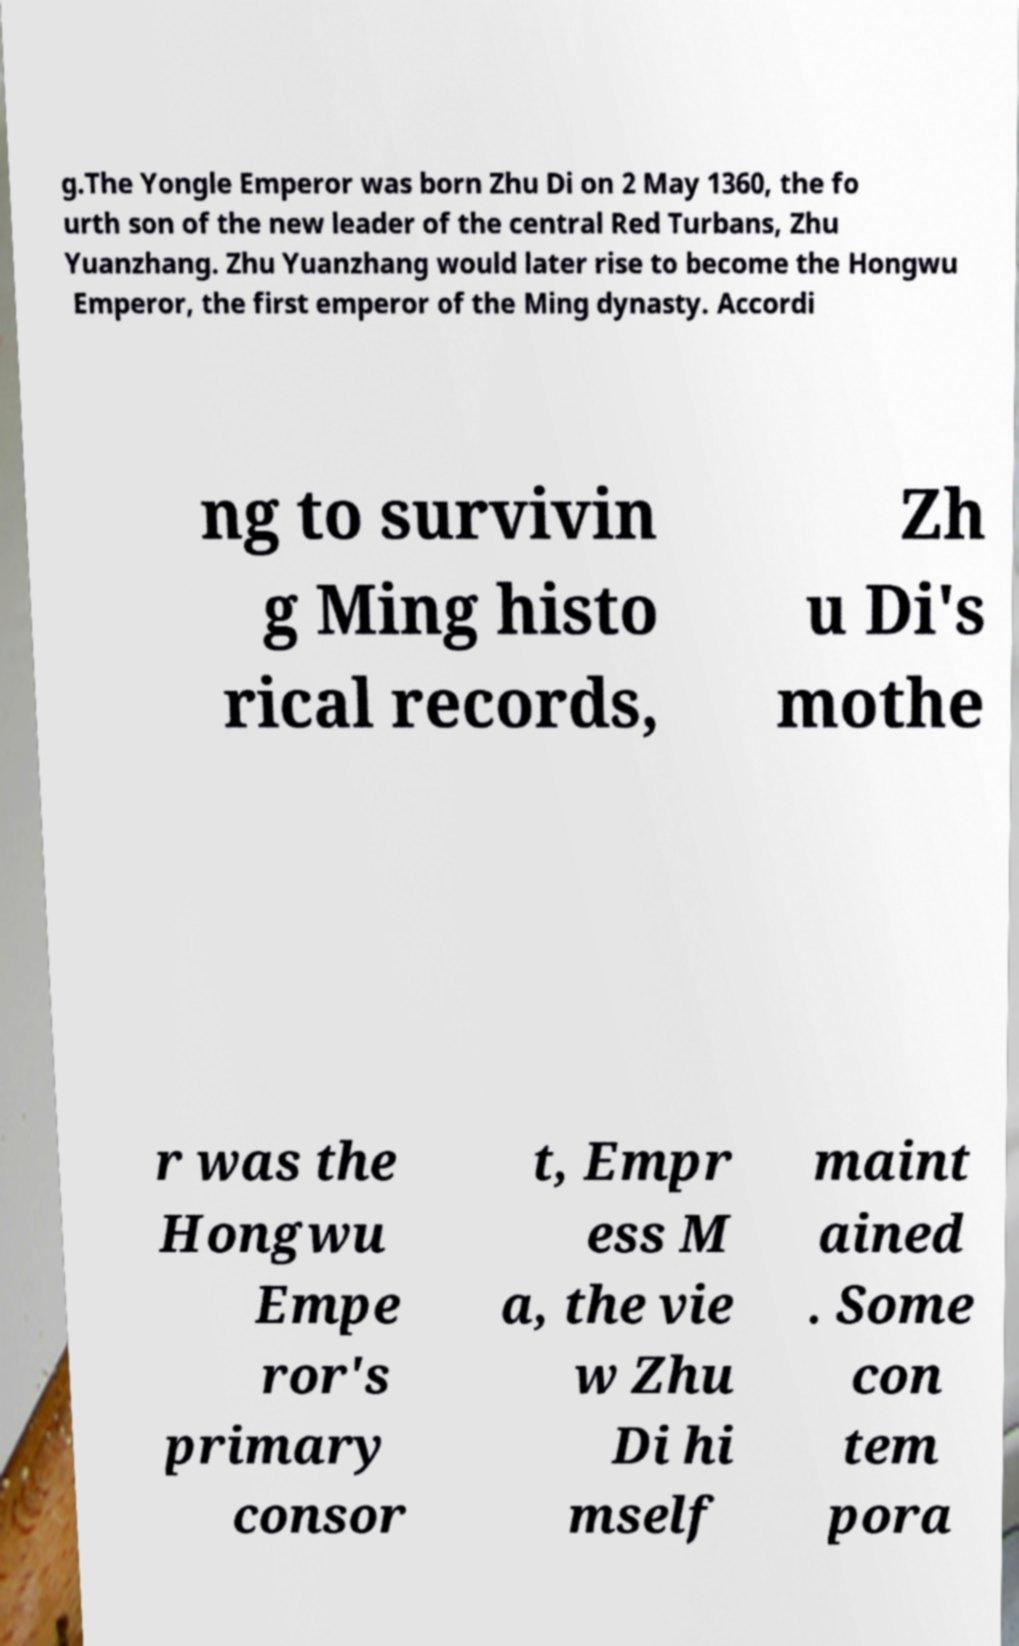What messages or text are displayed in this image? I need them in a readable, typed format. g.The Yongle Emperor was born Zhu Di on 2 May 1360, the fo urth son of the new leader of the central Red Turbans, Zhu Yuanzhang. Zhu Yuanzhang would later rise to become the Hongwu Emperor, the first emperor of the Ming dynasty. Accordi ng to survivin g Ming histo rical records, Zh u Di's mothe r was the Hongwu Empe ror's primary consor t, Empr ess M a, the vie w Zhu Di hi mself maint ained . Some con tem pora 